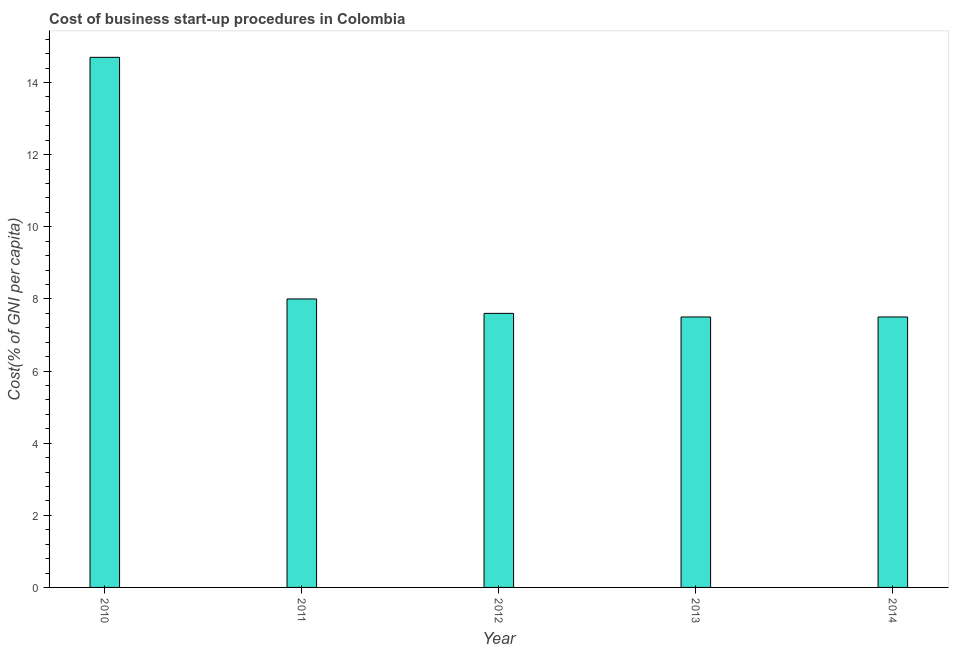Does the graph contain any zero values?
Offer a very short reply. No. What is the title of the graph?
Your response must be concise. Cost of business start-up procedures in Colombia. What is the label or title of the X-axis?
Ensure brevity in your answer.  Year. What is the label or title of the Y-axis?
Make the answer very short. Cost(% of GNI per capita). Across all years, what is the minimum cost of business startup procedures?
Keep it short and to the point. 7.5. In which year was the cost of business startup procedures maximum?
Offer a terse response. 2010. What is the sum of the cost of business startup procedures?
Keep it short and to the point. 45.3. What is the average cost of business startup procedures per year?
Your answer should be very brief. 9.06. Do a majority of the years between 2011 and 2012 (inclusive) have cost of business startup procedures greater than 7.6 %?
Keep it short and to the point. No. What is the ratio of the cost of business startup procedures in 2011 to that in 2012?
Your response must be concise. 1.05. Is the cost of business startup procedures in 2010 less than that in 2012?
Provide a short and direct response. No. Is the difference between the cost of business startup procedures in 2011 and 2014 greater than the difference between any two years?
Ensure brevity in your answer.  No. Is the sum of the cost of business startup procedures in 2012 and 2014 greater than the maximum cost of business startup procedures across all years?
Make the answer very short. Yes. In how many years, is the cost of business startup procedures greater than the average cost of business startup procedures taken over all years?
Provide a succinct answer. 1. How many bars are there?
Make the answer very short. 5. Are all the bars in the graph horizontal?
Your answer should be compact. No. What is the Cost(% of GNI per capita) in 2011?
Your response must be concise. 8. What is the difference between the Cost(% of GNI per capita) in 2010 and 2013?
Your answer should be compact. 7.2. What is the difference between the Cost(% of GNI per capita) in 2011 and 2012?
Ensure brevity in your answer.  0.4. What is the difference between the Cost(% of GNI per capita) in 2012 and 2013?
Your response must be concise. 0.1. What is the difference between the Cost(% of GNI per capita) in 2012 and 2014?
Your answer should be compact. 0.1. What is the difference between the Cost(% of GNI per capita) in 2013 and 2014?
Offer a very short reply. 0. What is the ratio of the Cost(% of GNI per capita) in 2010 to that in 2011?
Provide a short and direct response. 1.84. What is the ratio of the Cost(% of GNI per capita) in 2010 to that in 2012?
Provide a succinct answer. 1.93. What is the ratio of the Cost(% of GNI per capita) in 2010 to that in 2013?
Offer a terse response. 1.96. What is the ratio of the Cost(% of GNI per capita) in 2010 to that in 2014?
Keep it short and to the point. 1.96. What is the ratio of the Cost(% of GNI per capita) in 2011 to that in 2012?
Keep it short and to the point. 1.05. What is the ratio of the Cost(% of GNI per capita) in 2011 to that in 2013?
Offer a very short reply. 1.07. What is the ratio of the Cost(% of GNI per capita) in 2011 to that in 2014?
Offer a very short reply. 1.07. What is the ratio of the Cost(% of GNI per capita) in 2012 to that in 2014?
Your response must be concise. 1.01. 